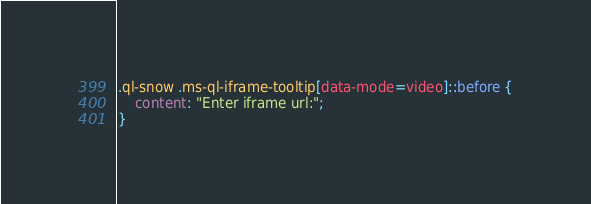<code> <loc_0><loc_0><loc_500><loc_500><_CSS_>

.ql-snow .ms-ql-iframe-tooltip[data-mode=video]::before {
    content: "Enter iframe url:";
}


</code> 